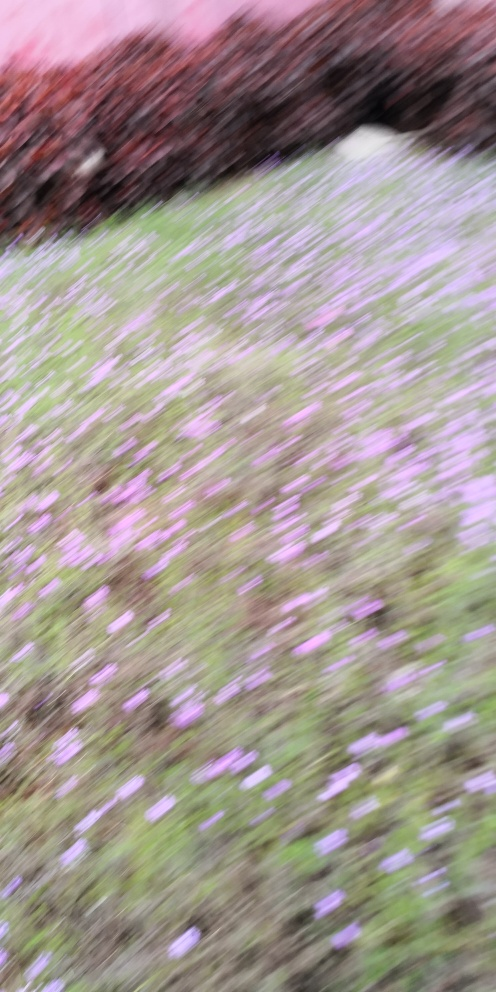What is the best approach to evaluate the composition of an image like this? While it's tough due to the quality, one can try to identify key elements such as color contrasts, the distribution of space, and any discernible patterns or textures that survive the blur. Could this image have any artistic value or use? Certainly. Abstract art often embraces elements such as blur and obscured details to evoke emotions and interpretative responses from the viewer. 